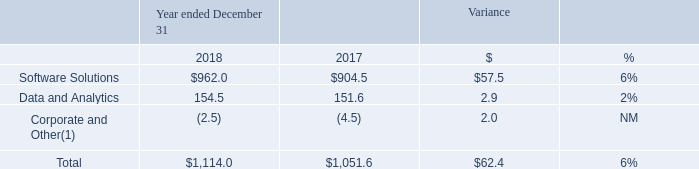Segment Financial Results
Revenues
The following table sets forth revenues by segment for the periods presented (in millions):
(1) Revenues for Corporate and Other represent deferred revenue purchase accounting adjustments recorded in accordance with GAAP.
Software Solutions
Revenues were $962.0 million in 2018 compared to $904.5 million in 2017, an increase of $57.5 million, or 6%. Our servicing software solutions revenues increased 7%, or $52.5 million, primarily driven by loan growth on MSP® from new and existing  clients. Our origination software solutions revenues increased 3%, or $5.0 million, primarily driven by growth in our loan origination system solutions and a software license fee in our Lending Solutions business, partially offset by the effect of lower volumes on our Exchange and eLending platforms primarily as a result of the 26% decline in refinancing originations as reported by the Mortgage Bankers Association.
Data and Analytics
Revenues were $154.5 million in 2018 compared to $151.6 million in 2017, an increase of $2.9 million, or 2%. The increase was primarily driven by growth in our property data and multiple listing service businesses, partially offset by upfront revenues from long-term strategic license deals in 2017.
What did revenues for Corporate and Other represent? Deferred revenue purchase accounting adjustments recorded in accordance with gaap. What was revenue from Software Solutions in 2018?
Answer scale should be: million. 962.0. What was revenue from Data and Analytics in 2017?
Answer scale should be: million. 151.6. How many years did revenue from Data and Analytics exceed $150 million? 2018##2017
Answer: 2. What was the average total revenue between 2017 and 2018?
Answer scale should be: million. (1,114.0+1,051.6)/2
Answer: 1082.8. What was the average revenue from Corporate and Other between 2017 and 2018?
Answer scale should be: million. (-2.5+(-4.5))/2
Answer: -3.5. 